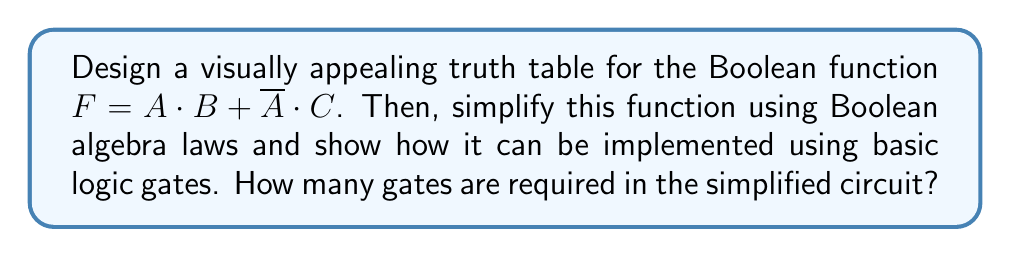What is the answer to this math problem? Let's approach this step-by-step:

1. First, we create a truth table for the function $F = A \cdot B + \overline{A} \cdot C$:

   $$
   \begin{array}{|c|c|c|c|}
   \hline
   A & B & C & F \\
   \hline
   0 & 0 & 0 & 0 \\
   0 & 0 & 1 & 1 \\
   0 & 1 & 0 & 0 \\
   0 & 1 & 1 & 1 \\
   1 & 0 & 0 & 0 \\
   1 & 0 & 1 & 0 \\
   1 & 1 & 0 & 1 \\
   1 & 1 & 1 & 1 \\
   \hline
   \end{array}
   $$

2. Now, let's simplify the function using Boolean algebra laws:

   $F = A \cdot B + \overline{A} \cdot C$
   
   We can't simplify this further using basic Boolean algebra laws.

3. To implement this function using basic logic gates, we need:
   - One NOT gate for $\overline{A}$
   - Two AND gates (one for $A \cdot B$, one for $\overline{A} \cdot C$)
   - One OR gate to combine the results of the AND gates

4. The circuit can be represented as:

   [asy]
   import geometry;

   // Define points
   pair A = (0,0), B = (0,-20), C = (0,-40);
   pair notA = (40,-10);
   pair and1 = (80,0), and2 = (80,-30);
   pair or1 = (120,-15);
   pair F = (160,-15);

   // Draw gates
   draw(circle(notA,10));
   draw((30,-10)--(50,-10));
   
   draw(box((70,-10),(90,10)));
   draw(box((70,-40),(90,-20)));
   draw(box((110,-25),(130,-5)));

   // Draw lines
   draw(A--and1);
   draw(B--(40,0)--(70,0));
   draw(C--(70,-30));
   draw((0,-10)--notA);
   draw((50,-10)--(70,-20));
   draw((90,0)--(100,0)--(100,-10)--(110,-10));
   draw((90,-30)--(100,-30)--(100,-20)--(110,-20));
   draw((130,-15)--F);

   // Labels
   label("A", A, W);
   label("B", B, W);
   label("C", C, W);
   label("F", F, E);
   label("&", (80,0));
   label("&", (80,-30));
   label("≥1", (120,-15));
   [/asy]

5. Counting the gates:
   - 1 NOT gate
   - 2 AND gates
   - 1 OR gate

   Total: 4 gates
Answer: 4 gates 